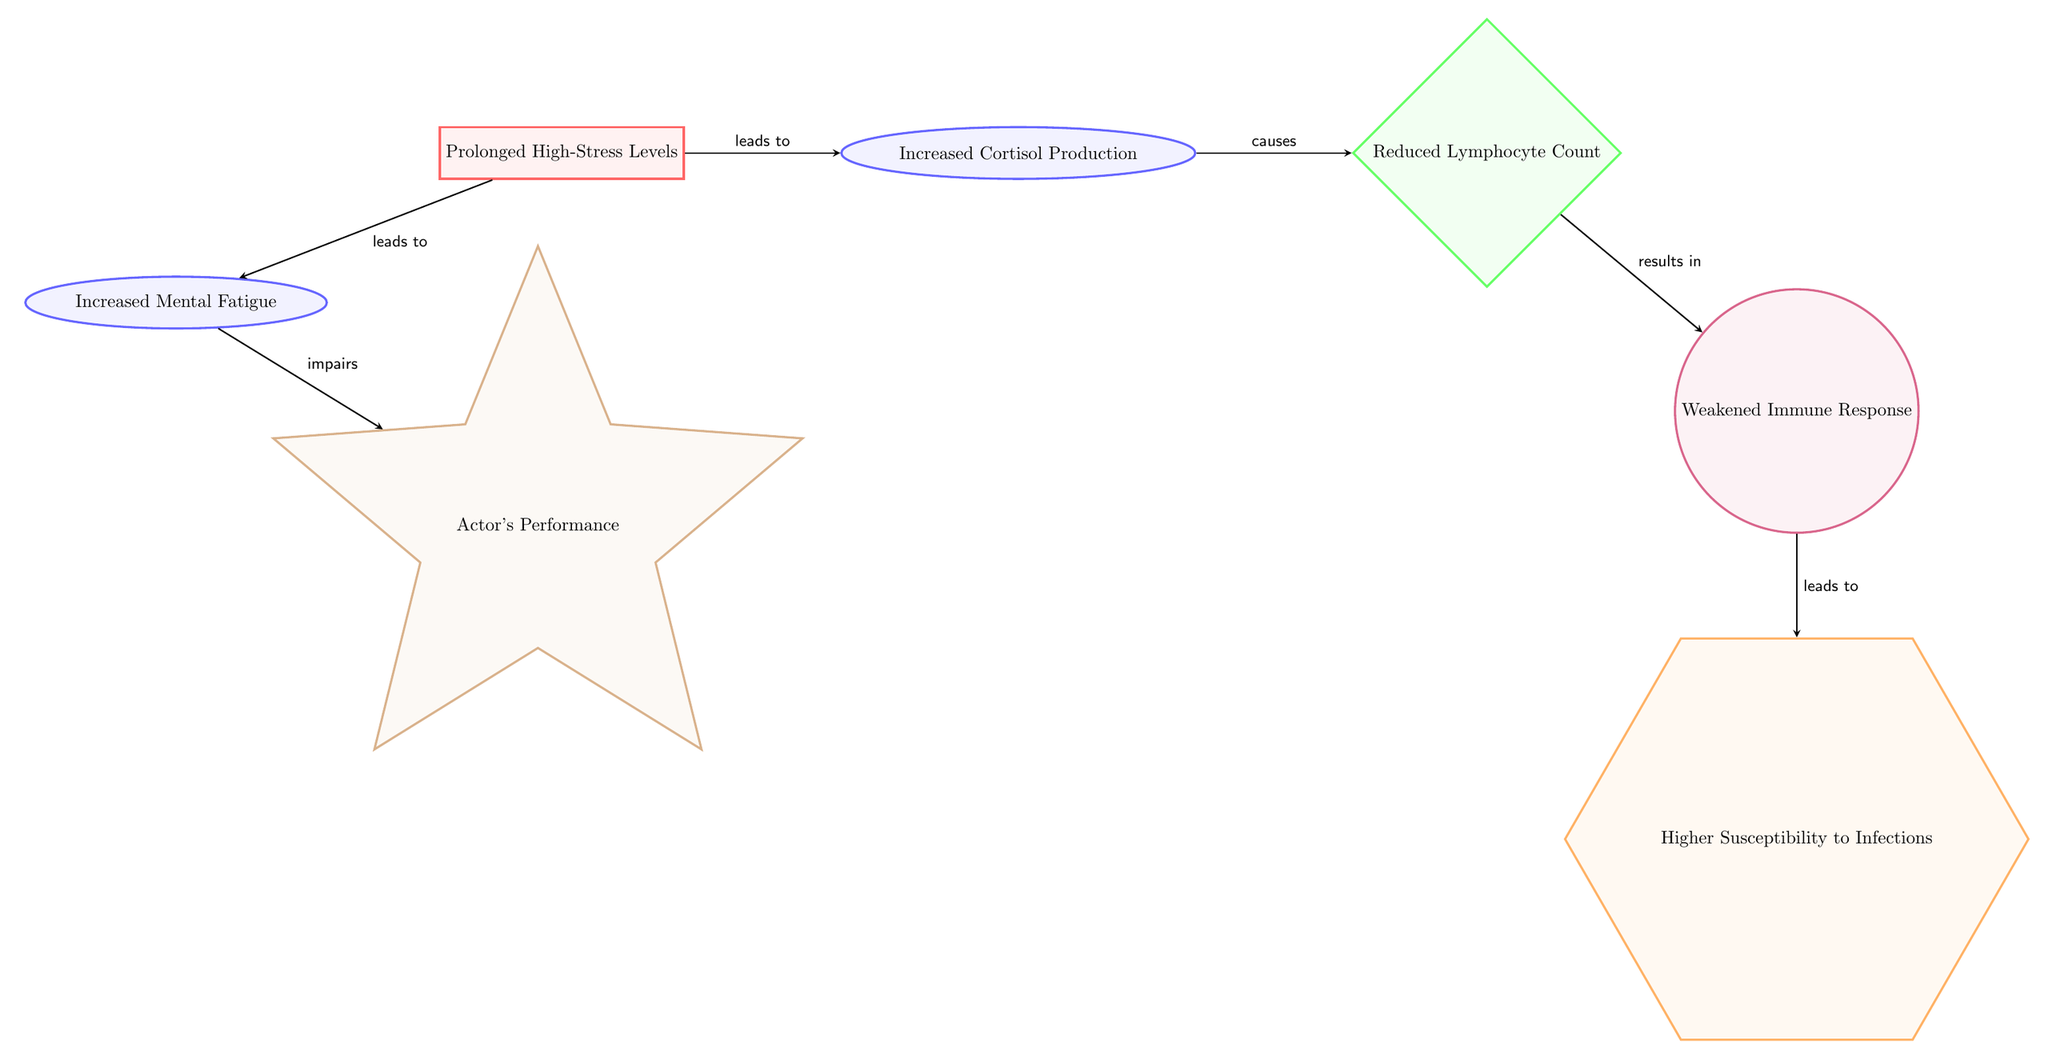What is the first node in the diagram? The first node, indicating the initial condition or cause in the diagram, is labeled "Prolonged High-Stress Levels." This is clearly visible at the beginning of the flow.
Answer: Prolonged High-Stress Levels How many total nodes are in the diagram? By counting all the distinct shapes representing different elements in the diagram, we find there are 6 nodes total: one cause, four effects/results, and one consequence.
Answer: 6 What does increased cortisol production result in? Tracing the flow from the node "Increased Cortisol Production," we find that it leads to a reduction in lymphocyte count, indicating a decrease in a critical component of the immune system.
Answer: Reduced Lymphocyte Count What are the consequences of a weakened immune response? The flow chart indicates that a "Weakened Immune Response" leads to "Higher Susceptibility to Infections," demonstrating a direct outcome of compromised immunity.
Answer: Higher Susceptibility to Infections What effect does increased mental fatigue have on actors? The "Increased Mental Fatigue" node directly connects to "Actor's Performance," indicating that mental fatigue can impair their performance quality.
Answer: Impairs What is the relationship between prolonged high-stress levels and increased mental fatigue? Prolonged high-stress levels lead to increased mental fatigue, as indicated by the arrow connecting these two nodes in the diagram. This shows that one directly causes the other.
Answer: Leads to How many arrows are there in the diagram? By counting the directional arrows that indicate relationships between nodes, we find that there are 5 arrows present in total.
Answer: 5 